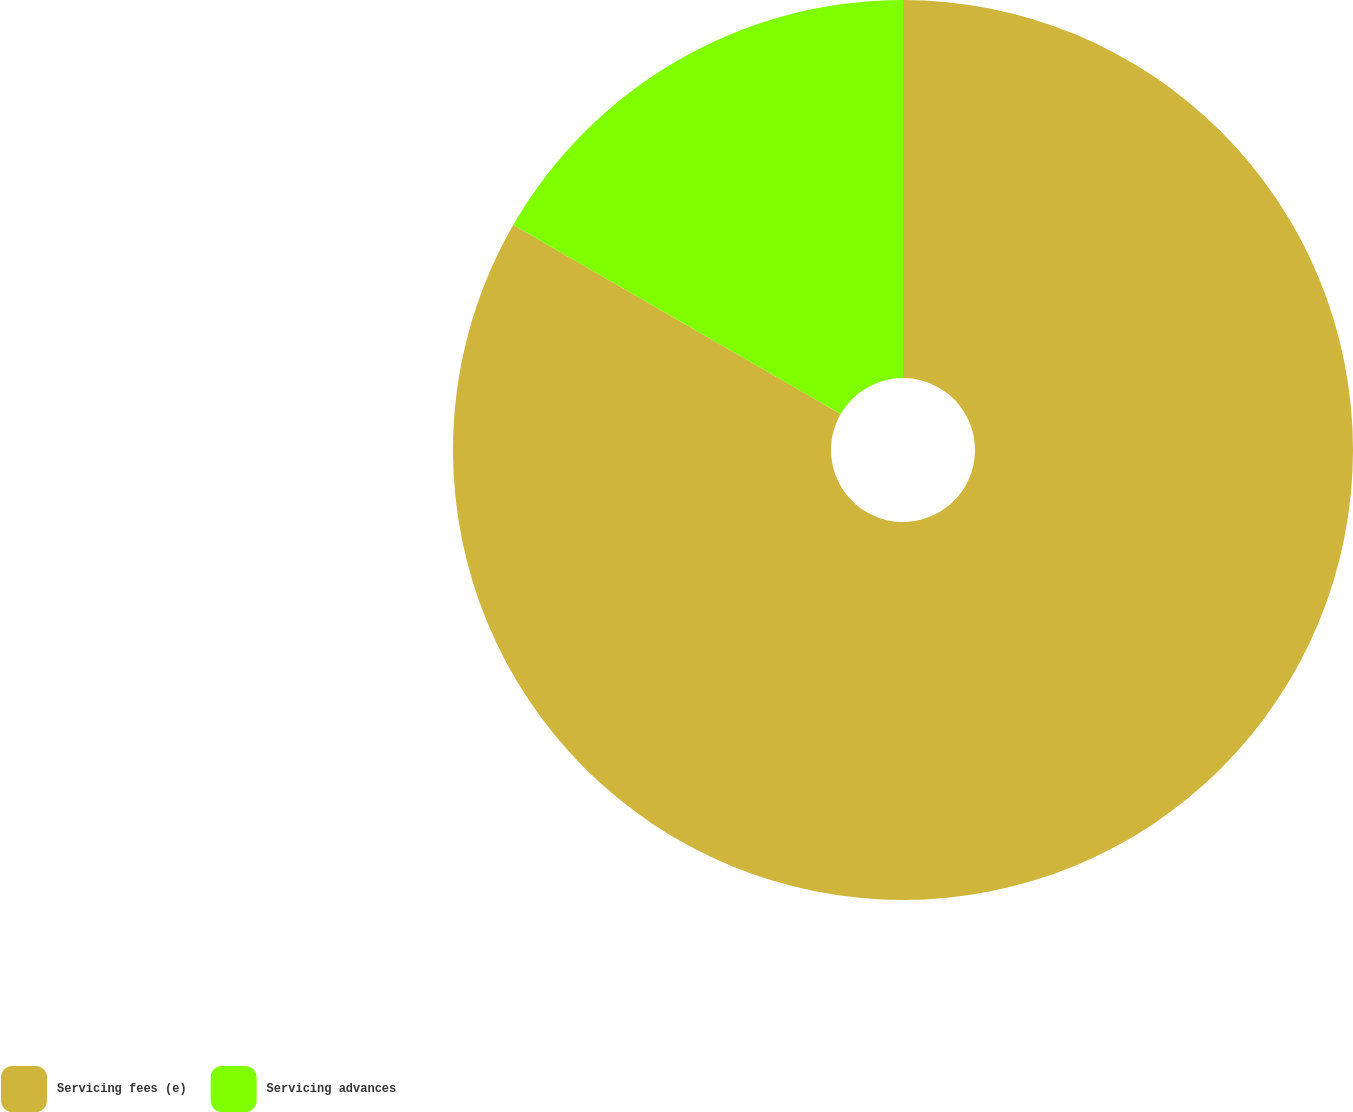Convert chart. <chart><loc_0><loc_0><loc_500><loc_500><pie_chart><fcel>Servicing fees (e)<fcel>Servicing advances<nl><fcel>83.33%<fcel>16.67%<nl></chart> 